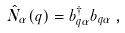<formula> <loc_0><loc_0><loc_500><loc_500>\hat { N } _ { \alpha } ( q ) = b ^ { \dag } _ { q \alpha } b _ { q \alpha } \, ,</formula> 